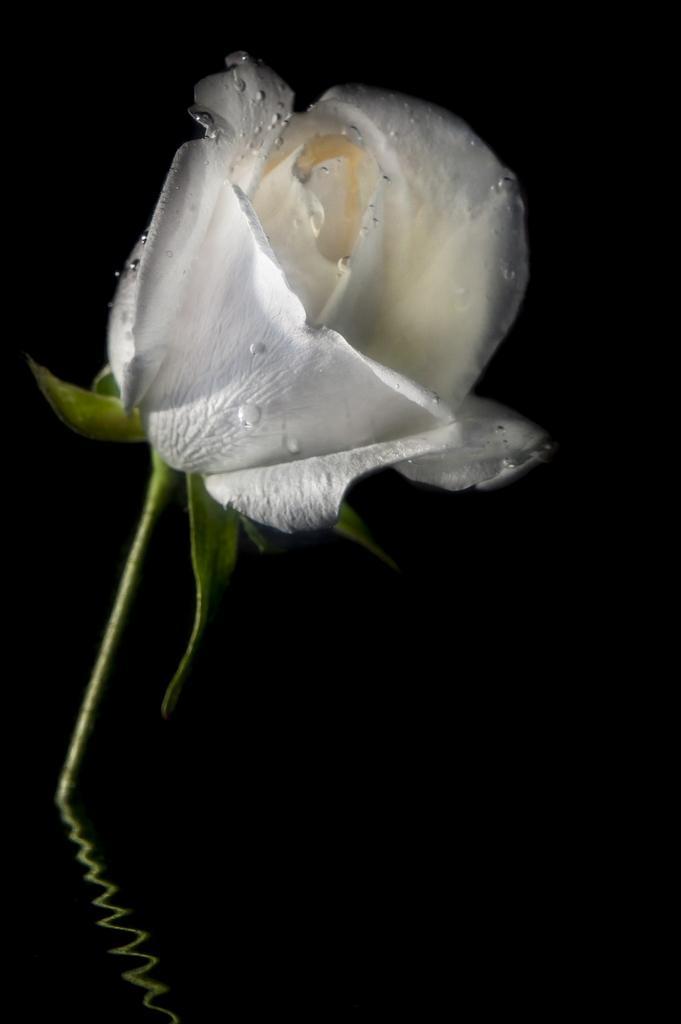Can you describe this image briefly? In the image in the center we can see water. In the water,we can see one white rose. 